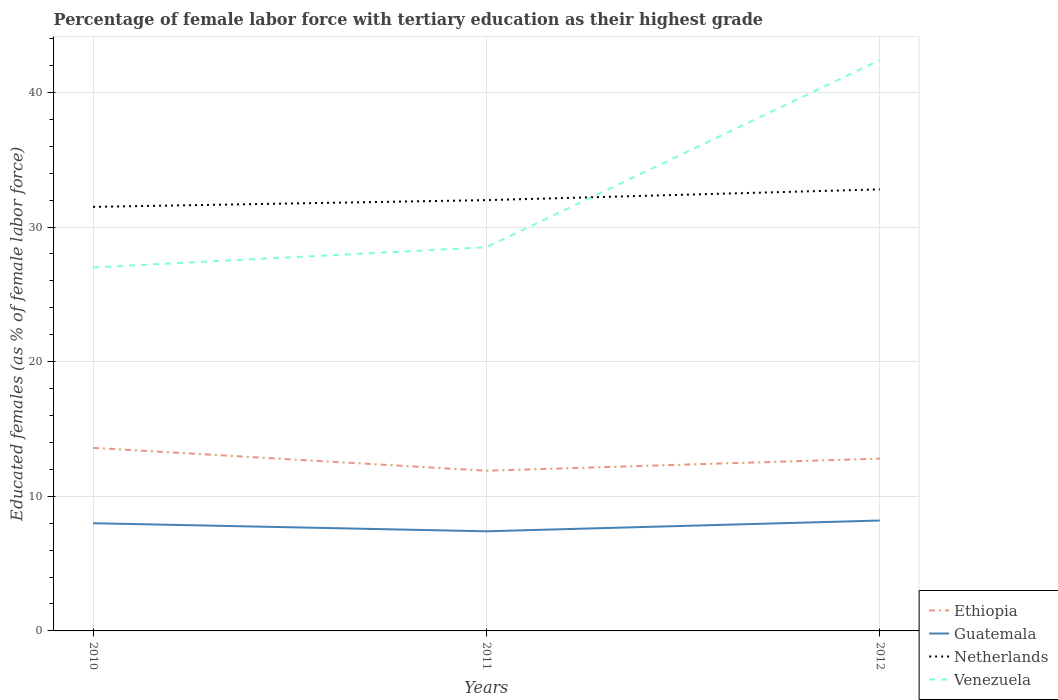How many different coloured lines are there?
Make the answer very short. 4. Is the number of lines equal to the number of legend labels?
Give a very brief answer. Yes. Across all years, what is the maximum percentage of female labor force with tertiary education in Netherlands?
Give a very brief answer. 31.5. What is the total percentage of female labor force with tertiary education in Venezuela in the graph?
Offer a very short reply. -13.9. What is the difference between the highest and the second highest percentage of female labor force with tertiary education in Ethiopia?
Your answer should be very brief. 1.7. What is the difference between the highest and the lowest percentage of female labor force with tertiary education in Venezuela?
Keep it short and to the point. 1. How many lines are there?
Keep it short and to the point. 4. How many years are there in the graph?
Give a very brief answer. 3. Are the values on the major ticks of Y-axis written in scientific E-notation?
Your answer should be very brief. No. Does the graph contain grids?
Keep it short and to the point. Yes. Where does the legend appear in the graph?
Your answer should be very brief. Bottom right. How many legend labels are there?
Keep it short and to the point. 4. What is the title of the graph?
Your answer should be very brief. Percentage of female labor force with tertiary education as their highest grade. What is the label or title of the X-axis?
Provide a succinct answer. Years. What is the label or title of the Y-axis?
Ensure brevity in your answer.  Educated females (as % of female labor force). What is the Educated females (as % of female labor force) in Ethiopia in 2010?
Your answer should be compact. 13.6. What is the Educated females (as % of female labor force) in Guatemala in 2010?
Provide a short and direct response. 8. What is the Educated females (as % of female labor force) in Netherlands in 2010?
Offer a terse response. 31.5. What is the Educated females (as % of female labor force) in Venezuela in 2010?
Give a very brief answer. 27. What is the Educated females (as % of female labor force) of Ethiopia in 2011?
Keep it short and to the point. 11.9. What is the Educated females (as % of female labor force) in Guatemala in 2011?
Provide a succinct answer. 7.4. What is the Educated females (as % of female labor force) of Ethiopia in 2012?
Your answer should be very brief. 12.8. What is the Educated females (as % of female labor force) of Guatemala in 2012?
Provide a succinct answer. 8.2. What is the Educated females (as % of female labor force) in Netherlands in 2012?
Make the answer very short. 32.8. What is the Educated females (as % of female labor force) in Venezuela in 2012?
Offer a terse response. 42.4. Across all years, what is the maximum Educated females (as % of female labor force) in Ethiopia?
Provide a short and direct response. 13.6. Across all years, what is the maximum Educated females (as % of female labor force) in Guatemala?
Offer a very short reply. 8.2. Across all years, what is the maximum Educated females (as % of female labor force) in Netherlands?
Give a very brief answer. 32.8. Across all years, what is the maximum Educated females (as % of female labor force) in Venezuela?
Your answer should be compact. 42.4. Across all years, what is the minimum Educated females (as % of female labor force) in Ethiopia?
Provide a succinct answer. 11.9. Across all years, what is the minimum Educated females (as % of female labor force) in Guatemala?
Give a very brief answer. 7.4. Across all years, what is the minimum Educated females (as % of female labor force) of Netherlands?
Provide a short and direct response. 31.5. What is the total Educated females (as % of female labor force) of Ethiopia in the graph?
Provide a short and direct response. 38.3. What is the total Educated females (as % of female labor force) in Guatemala in the graph?
Make the answer very short. 23.6. What is the total Educated females (as % of female labor force) of Netherlands in the graph?
Your answer should be compact. 96.3. What is the total Educated females (as % of female labor force) of Venezuela in the graph?
Offer a very short reply. 97.9. What is the difference between the Educated females (as % of female labor force) in Ethiopia in 2010 and that in 2011?
Provide a short and direct response. 1.7. What is the difference between the Educated females (as % of female labor force) in Netherlands in 2010 and that in 2012?
Your answer should be compact. -1.3. What is the difference between the Educated females (as % of female labor force) of Venezuela in 2010 and that in 2012?
Offer a terse response. -15.4. What is the difference between the Educated females (as % of female labor force) in Guatemala in 2011 and that in 2012?
Offer a very short reply. -0.8. What is the difference between the Educated females (as % of female labor force) of Netherlands in 2011 and that in 2012?
Your answer should be very brief. -0.8. What is the difference between the Educated females (as % of female labor force) in Venezuela in 2011 and that in 2012?
Provide a short and direct response. -13.9. What is the difference between the Educated females (as % of female labor force) of Ethiopia in 2010 and the Educated females (as % of female labor force) of Guatemala in 2011?
Keep it short and to the point. 6.2. What is the difference between the Educated females (as % of female labor force) in Ethiopia in 2010 and the Educated females (as % of female labor force) in Netherlands in 2011?
Your answer should be very brief. -18.4. What is the difference between the Educated females (as % of female labor force) in Ethiopia in 2010 and the Educated females (as % of female labor force) in Venezuela in 2011?
Provide a short and direct response. -14.9. What is the difference between the Educated females (as % of female labor force) in Guatemala in 2010 and the Educated females (as % of female labor force) in Venezuela in 2011?
Keep it short and to the point. -20.5. What is the difference between the Educated females (as % of female labor force) in Netherlands in 2010 and the Educated females (as % of female labor force) in Venezuela in 2011?
Provide a short and direct response. 3. What is the difference between the Educated females (as % of female labor force) in Ethiopia in 2010 and the Educated females (as % of female labor force) in Guatemala in 2012?
Offer a terse response. 5.4. What is the difference between the Educated females (as % of female labor force) in Ethiopia in 2010 and the Educated females (as % of female labor force) in Netherlands in 2012?
Provide a succinct answer. -19.2. What is the difference between the Educated females (as % of female labor force) in Ethiopia in 2010 and the Educated females (as % of female labor force) in Venezuela in 2012?
Your response must be concise. -28.8. What is the difference between the Educated females (as % of female labor force) in Guatemala in 2010 and the Educated females (as % of female labor force) in Netherlands in 2012?
Make the answer very short. -24.8. What is the difference between the Educated females (as % of female labor force) in Guatemala in 2010 and the Educated females (as % of female labor force) in Venezuela in 2012?
Your response must be concise. -34.4. What is the difference between the Educated females (as % of female labor force) of Ethiopia in 2011 and the Educated females (as % of female labor force) of Guatemala in 2012?
Give a very brief answer. 3.7. What is the difference between the Educated females (as % of female labor force) in Ethiopia in 2011 and the Educated females (as % of female labor force) in Netherlands in 2012?
Offer a very short reply. -20.9. What is the difference between the Educated females (as % of female labor force) of Ethiopia in 2011 and the Educated females (as % of female labor force) of Venezuela in 2012?
Your answer should be compact. -30.5. What is the difference between the Educated females (as % of female labor force) in Guatemala in 2011 and the Educated females (as % of female labor force) in Netherlands in 2012?
Provide a short and direct response. -25.4. What is the difference between the Educated females (as % of female labor force) of Guatemala in 2011 and the Educated females (as % of female labor force) of Venezuela in 2012?
Offer a very short reply. -35. What is the difference between the Educated females (as % of female labor force) of Netherlands in 2011 and the Educated females (as % of female labor force) of Venezuela in 2012?
Keep it short and to the point. -10.4. What is the average Educated females (as % of female labor force) of Ethiopia per year?
Offer a very short reply. 12.77. What is the average Educated females (as % of female labor force) in Guatemala per year?
Provide a succinct answer. 7.87. What is the average Educated females (as % of female labor force) in Netherlands per year?
Your answer should be compact. 32.1. What is the average Educated females (as % of female labor force) of Venezuela per year?
Keep it short and to the point. 32.63. In the year 2010, what is the difference between the Educated females (as % of female labor force) of Ethiopia and Educated females (as % of female labor force) of Netherlands?
Your answer should be very brief. -17.9. In the year 2010, what is the difference between the Educated females (as % of female labor force) in Guatemala and Educated females (as % of female labor force) in Netherlands?
Offer a very short reply. -23.5. In the year 2010, what is the difference between the Educated females (as % of female labor force) in Guatemala and Educated females (as % of female labor force) in Venezuela?
Your answer should be very brief. -19. In the year 2011, what is the difference between the Educated females (as % of female labor force) of Ethiopia and Educated females (as % of female labor force) of Guatemala?
Provide a short and direct response. 4.5. In the year 2011, what is the difference between the Educated females (as % of female labor force) of Ethiopia and Educated females (as % of female labor force) of Netherlands?
Provide a short and direct response. -20.1. In the year 2011, what is the difference between the Educated females (as % of female labor force) in Ethiopia and Educated females (as % of female labor force) in Venezuela?
Offer a very short reply. -16.6. In the year 2011, what is the difference between the Educated females (as % of female labor force) in Guatemala and Educated females (as % of female labor force) in Netherlands?
Offer a very short reply. -24.6. In the year 2011, what is the difference between the Educated females (as % of female labor force) in Guatemala and Educated females (as % of female labor force) in Venezuela?
Offer a very short reply. -21.1. In the year 2011, what is the difference between the Educated females (as % of female labor force) in Netherlands and Educated females (as % of female labor force) in Venezuela?
Your answer should be very brief. 3.5. In the year 2012, what is the difference between the Educated females (as % of female labor force) in Ethiopia and Educated females (as % of female labor force) in Venezuela?
Ensure brevity in your answer.  -29.6. In the year 2012, what is the difference between the Educated females (as % of female labor force) of Guatemala and Educated females (as % of female labor force) of Netherlands?
Your response must be concise. -24.6. In the year 2012, what is the difference between the Educated females (as % of female labor force) in Guatemala and Educated females (as % of female labor force) in Venezuela?
Your answer should be compact. -34.2. In the year 2012, what is the difference between the Educated females (as % of female labor force) of Netherlands and Educated females (as % of female labor force) of Venezuela?
Provide a short and direct response. -9.6. What is the ratio of the Educated females (as % of female labor force) in Ethiopia in 2010 to that in 2011?
Your answer should be very brief. 1.14. What is the ratio of the Educated females (as % of female labor force) of Guatemala in 2010 to that in 2011?
Give a very brief answer. 1.08. What is the ratio of the Educated females (as % of female labor force) of Netherlands in 2010 to that in 2011?
Ensure brevity in your answer.  0.98. What is the ratio of the Educated females (as % of female labor force) of Ethiopia in 2010 to that in 2012?
Make the answer very short. 1.06. What is the ratio of the Educated females (as % of female labor force) in Guatemala in 2010 to that in 2012?
Provide a short and direct response. 0.98. What is the ratio of the Educated females (as % of female labor force) in Netherlands in 2010 to that in 2012?
Provide a succinct answer. 0.96. What is the ratio of the Educated females (as % of female labor force) of Venezuela in 2010 to that in 2012?
Offer a very short reply. 0.64. What is the ratio of the Educated females (as % of female labor force) in Ethiopia in 2011 to that in 2012?
Make the answer very short. 0.93. What is the ratio of the Educated females (as % of female labor force) of Guatemala in 2011 to that in 2012?
Your response must be concise. 0.9. What is the ratio of the Educated females (as % of female labor force) of Netherlands in 2011 to that in 2012?
Keep it short and to the point. 0.98. What is the ratio of the Educated females (as % of female labor force) of Venezuela in 2011 to that in 2012?
Offer a very short reply. 0.67. What is the difference between the highest and the second highest Educated females (as % of female labor force) in Ethiopia?
Ensure brevity in your answer.  0.8. What is the difference between the highest and the second highest Educated females (as % of female labor force) of Guatemala?
Make the answer very short. 0.2. What is the difference between the highest and the second highest Educated females (as % of female labor force) of Netherlands?
Keep it short and to the point. 0.8. What is the difference between the highest and the lowest Educated females (as % of female labor force) of Venezuela?
Keep it short and to the point. 15.4. 